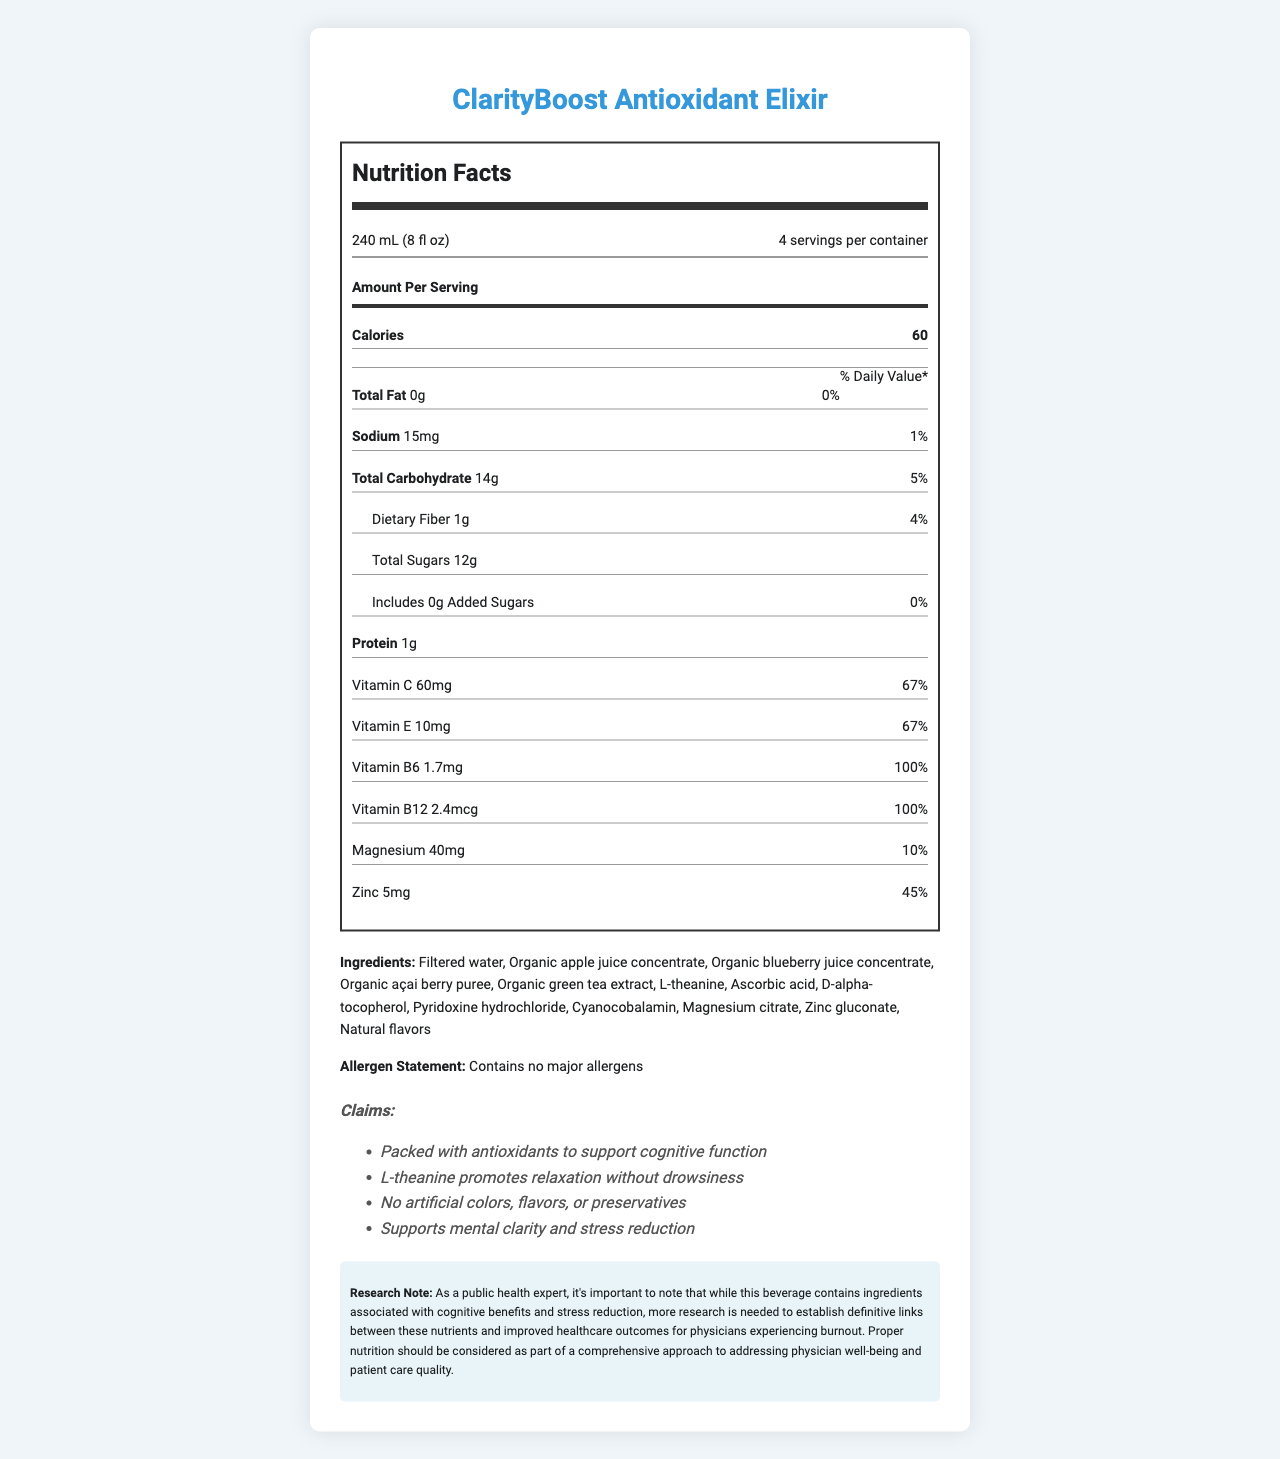what is the serving size of ClarityBoost Antioxidant Elixir? The serving size is listed at the top of the Nutrition Facts label under "Serving Size".
Answer: 240 mL (8 fl oz) how many calories are there per serving? The number of calories per serving is listed under "Amount Per Serving".
Answer: 60 what percentage of the daily value of Vitamin C does one serving provide? The daily value percentage for Vitamin C is provided on the Nutrition Facts label under "Vitamin C".
Answer: 67% what is the total carbohydrate content per serving? The total carbohydrate content is shown under "Total Carbohydrate" on the label.
Answer: 14g does the product contain any major allergens? The allergen statement clearly states "Contains no major allergens".
Answer: No what is the amount of protein per serving? The protein content is listed under "Protein" on the Nutrition Facts label.
Answer: 1g which vitamin is present at 100% of the daily value in this beverage? Both Vitamin B6 (1.7mg) and Vitamin B12 (2.4mcg) are listed at 100% daily value.
Answer: Vitamin B6 and Vitamin B12 how much dietary fiber does one serving of the beverage provide? The dietary fiber content is shown under "Dietary Fiber" in the Nutrition Facts label.
Answer: 1g which of the following are part of the key ingredients in ClarityBoost Antioxidant Elixir? A. Sugar, Green Tea Extract, Blueberry Juice B. Filtered Water, Apple Juice Concentrate, Magnesium Citrate C. Sugar, Açai Berry Puree, Vitamin C The list of ingredients includes Filtered Water, Apple Juice Concentrate, and Magnesium Citrate, but not Sugar in any significant quantity.
Answer: B what is the daily value percentage for Zinc per serving? A. 10% B. 45% C. 67% D. 100% The daily value percentage for Zinc is provided as 45%.
Answer: B the product claims to boost cognitive function; which ingredient specifically supports relaxation without drowsiness? The claim statements specify that "L-theanine promotes relaxation without drowsiness".
Answer: L-theanine does the ClarityBoost Antioxidant Elixir contain any added sugars? The label states 0g of added sugars under "Includes Added Sugars".
Answer: No provide a brief summary of what the Nutrition Facts Label tells us about ClarityBoost Antioxidant Elixir. The document contains a detailed Nutrition Facts label, claim statements, and a list of ingredients indicating the health benefits and nutritional content of the ClarityBoost Antioxidant Elixir.
Answer: ClarityBoost Antioxidant Elixir is a low-calorie beverage with claims to support mental clarity and reduce stress. It contains key ingredients such as filtered water, organic juice concentrates, and green tea extract. The beverage is high in antioxidants with significant amounts of Vitamin C, Vitamin E, Vitamin B6, and Vitamin B12. It has no added sugars or major allergens, contributing to its health claims. how many servings are there in one container of ClarityBoost Antioxidant Elixir? The document specifies that there are 4 servings per container under "Servings Per Container".
Answer: 4 what is the magnesium content per serving? The magnesium content per serving is listed under "Magnesium" in the Nutrition Facts label.
Answer: 40mg does the ClarityBoost Antioxidant Elixir contain artificial preservatives? The claim statements explicitly mention "No artificial colors, flavors, or preservatives".
Answer: No what is the link between these nutrients and improved healthcare outcomes for physicians experiencing burnout? The research note indicates that more research is needed to establish definitive links between these nutrients and improved healthcare outcomes for physicians experiencing burnout. The label does not provide this information.
Answer: Not enough information 